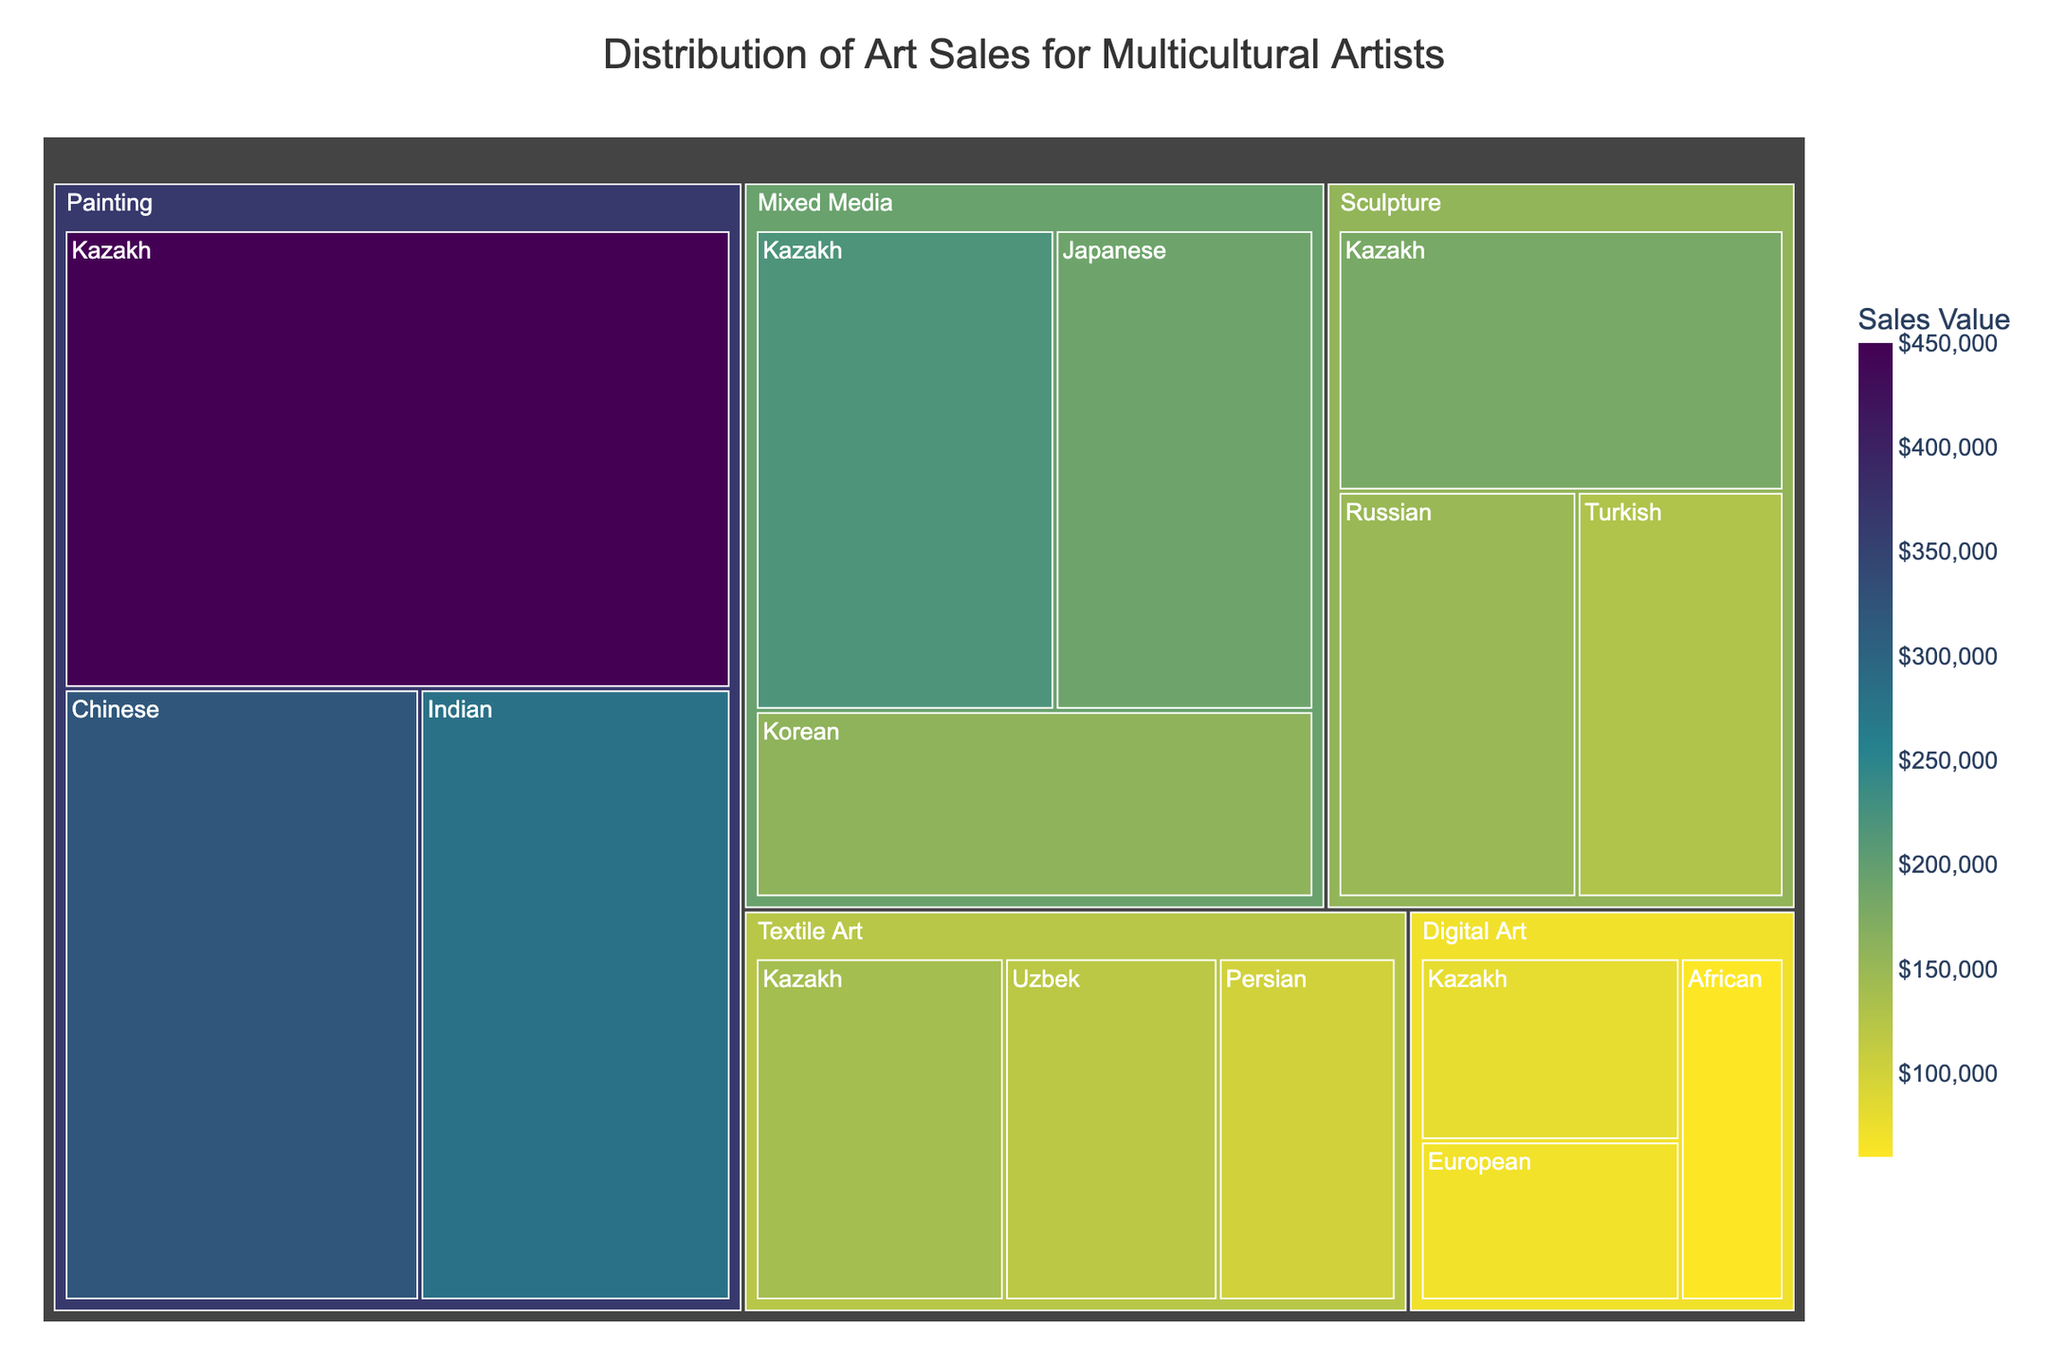What is the title of the treemap? The title of the treemap is displayed at the top center of the figure.
Answer: Distribution of Art Sales for Multicultural Artists How many media categories are represented in the treemap? The treemap shows the different media categories as the top-level segments.
Answer: Five Which cultural inspiration within the Painting medium has the highest sales value? Within the Painting segment, the size of the cells indicates sales value, and the Kazakh-inspired painting is the largest.
Answer: Kazakh What is the total sales value for Kazakh-inspired art across all media? Sum the sales values for Kazakh art in each medium: Painting (450,000) + Sculpture (180,000) + Mixed Media (220,000) + Textile Art (140,000) + Digital Art (80,000).
Answer: 1,070,000 How do the sales values of Kazakh-inspired sculptures compare to Russian-inspired sculptures? Compare the sizes of the segments within the Sculpture category for Kazakh and Russian-inspired art. Kazakh is larger indicating higher sales.
Answer: Kazakh-inspired sculptures have higher sales Which medium has the lowest total sales value? Aggregate the sales values within each medium and identify the one with the lowest total. Digital Art has the smallest segments suggesting the lowest sales.
Answer: Digital Art In the Mixed Media category, which cultural inspiration has the second highest sales value? Within the Mixed Media segment, the Kazakh-inspired segment is the largest, followed by the Japanese-inspired segment.
Answer: Japanese What is the combined sales value of Japanese and Korean-inspired art in the Mixed Media category? Sum the sales values of Japanese (190,000) and Korean (160,000) inspired art in the Mixed Media category.
Answer: 350,000 Which cultural inspirations in the Textile Art category have sales values less than 130,000? Examine the segments within the Textile Art category. Uzbek (120,000) and Persian (100,000) are both less than 130,000.
Answer: Uzbek and Persian Which medium has the most diverse range of cultural inspirations? Identify the medium with the highest number of distinct cultural inspiration segments. Textile Art has segments for Kazakh, Uzbek, and Persian, suggesting it is among the most diverse.
Answer: Textile Art 